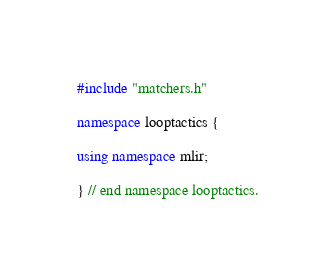Convert code to text. <code><loc_0><loc_0><loc_500><loc_500><_C++_>#include "matchers.h"

namespace looptactics {

using namespace mlir;

} // end namespace looptactics.
</code> 